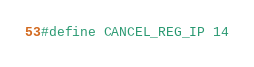<code> <loc_0><loc_0><loc_500><loc_500><_C_>
#define CANCEL_REG_IP 14
</code> 